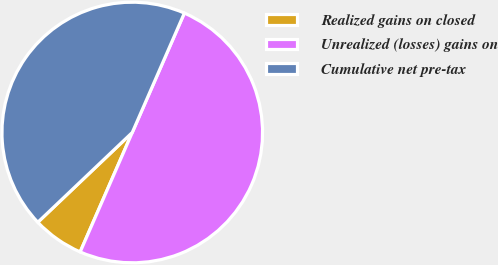Convert chart to OTSL. <chart><loc_0><loc_0><loc_500><loc_500><pie_chart><fcel>Realized gains on closed<fcel>Unrealized (losses) gains on<fcel>Cumulative net pre-tax<nl><fcel>6.36%<fcel>50.0%<fcel>43.64%<nl></chart> 